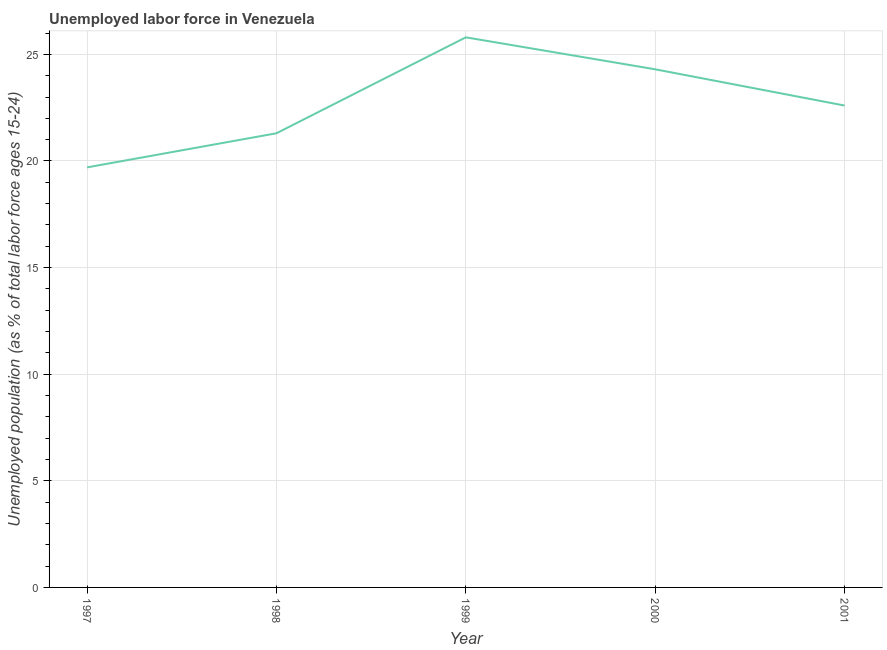What is the total unemployed youth population in 2000?
Give a very brief answer. 24.3. Across all years, what is the maximum total unemployed youth population?
Your answer should be compact. 25.8. Across all years, what is the minimum total unemployed youth population?
Provide a short and direct response. 19.7. In which year was the total unemployed youth population minimum?
Give a very brief answer. 1997. What is the sum of the total unemployed youth population?
Keep it short and to the point. 113.7. What is the difference between the total unemployed youth population in 1997 and 1999?
Your answer should be compact. -6.1. What is the average total unemployed youth population per year?
Give a very brief answer. 22.74. What is the median total unemployed youth population?
Your response must be concise. 22.6. In how many years, is the total unemployed youth population greater than 16 %?
Provide a short and direct response. 5. What is the ratio of the total unemployed youth population in 1997 to that in 2000?
Your response must be concise. 0.81. What is the difference between the highest and the lowest total unemployed youth population?
Your answer should be very brief. 6.1. In how many years, is the total unemployed youth population greater than the average total unemployed youth population taken over all years?
Give a very brief answer. 2. How many lines are there?
Keep it short and to the point. 1. How many years are there in the graph?
Make the answer very short. 5. What is the difference between two consecutive major ticks on the Y-axis?
Your answer should be very brief. 5. Are the values on the major ticks of Y-axis written in scientific E-notation?
Your answer should be compact. No. Does the graph contain any zero values?
Your answer should be compact. No. What is the title of the graph?
Offer a very short reply. Unemployed labor force in Venezuela. What is the label or title of the Y-axis?
Your answer should be very brief. Unemployed population (as % of total labor force ages 15-24). What is the Unemployed population (as % of total labor force ages 15-24) in 1997?
Provide a succinct answer. 19.7. What is the Unemployed population (as % of total labor force ages 15-24) in 1998?
Provide a succinct answer. 21.3. What is the Unemployed population (as % of total labor force ages 15-24) in 1999?
Provide a short and direct response. 25.8. What is the Unemployed population (as % of total labor force ages 15-24) in 2000?
Ensure brevity in your answer.  24.3. What is the Unemployed population (as % of total labor force ages 15-24) in 2001?
Offer a very short reply. 22.6. What is the difference between the Unemployed population (as % of total labor force ages 15-24) in 1997 and 1999?
Give a very brief answer. -6.1. What is the difference between the Unemployed population (as % of total labor force ages 15-24) in 1997 and 2000?
Your response must be concise. -4.6. What is the difference between the Unemployed population (as % of total labor force ages 15-24) in 1997 and 2001?
Make the answer very short. -2.9. What is the difference between the Unemployed population (as % of total labor force ages 15-24) in 1998 and 1999?
Your answer should be very brief. -4.5. What is the difference between the Unemployed population (as % of total labor force ages 15-24) in 1998 and 2001?
Offer a terse response. -1.3. What is the difference between the Unemployed population (as % of total labor force ages 15-24) in 1999 and 2001?
Your answer should be very brief. 3.2. What is the ratio of the Unemployed population (as % of total labor force ages 15-24) in 1997 to that in 1998?
Give a very brief answer. 0.93. What is the ratio of the Unemployed population (as % of total labor force ages 15-24) in 1997 to that in 1999?
Give a very brief answer. 0.76. What is the ratio of the Unemployed population (as % of total labor force ages 15-24) in 1997 to that in 2000?
Your answer should be compact. 0.81. What is the ratio of the Unemployed population (as % of total labor force ages 15-24) in 1997 to that in 2001?
Your response must be concise. 0.87. What is the ratio of the Unemployed population (as % of total labor force ages 15-24) in 1998 to that in 1999?
Your answer should be very brief. 0.83. What is the ratio of the Unemployed population (as % of total labor force ages 15-24) in 1998 to that in 2000?
Provide a short and direct response. 0.88. What is the ratio of the Unemployed population (as % of total labor force ages 15-24) in 1998 to that in 2001?
Give a very brief answer. 0.94. What is the ratio of the Unemployed population (as % of total labor force ages 15-24) in 1999 to that in 2000?
Offer a terse response. 1.06. What is the ratio of the Unemployed population (as % of total labor force ages 15-24) in 1999 to that in 2001?
Your answer should be compact. 1.14. What is the ratio of the Unemployed population (as % of total labor force ages 15-24) in 2000 to that in 2001?
Provide a short and direct response. 1.07. 